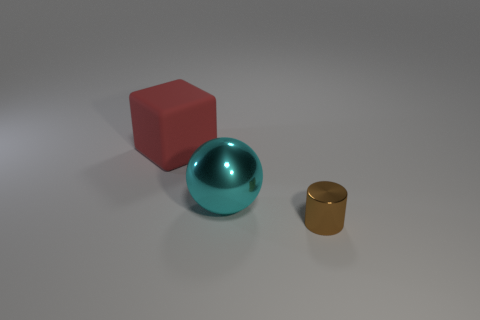Subtract 0 yellow spheres. How many objects are left? 3 Subtract all balls. How many objects are left? 2 Subtract 1 cylinders. How many cylinders are left? 0 Subtract all cyan cylinders. Subtract all yellow cubes. How many cylinders are left? 1 Subtract all blue balls. How many purple cubes are left? 0 Subtract all large cyan metallic things. Subtract all big red objects. How many objects are left? 1 Add 2 large rubber blocks. How many large rubber blocks are left? 3 Add 1 tiny brown things. How many tiny brown things exist? 2 Add 2 large blue spheres. How many objects exist? 5 